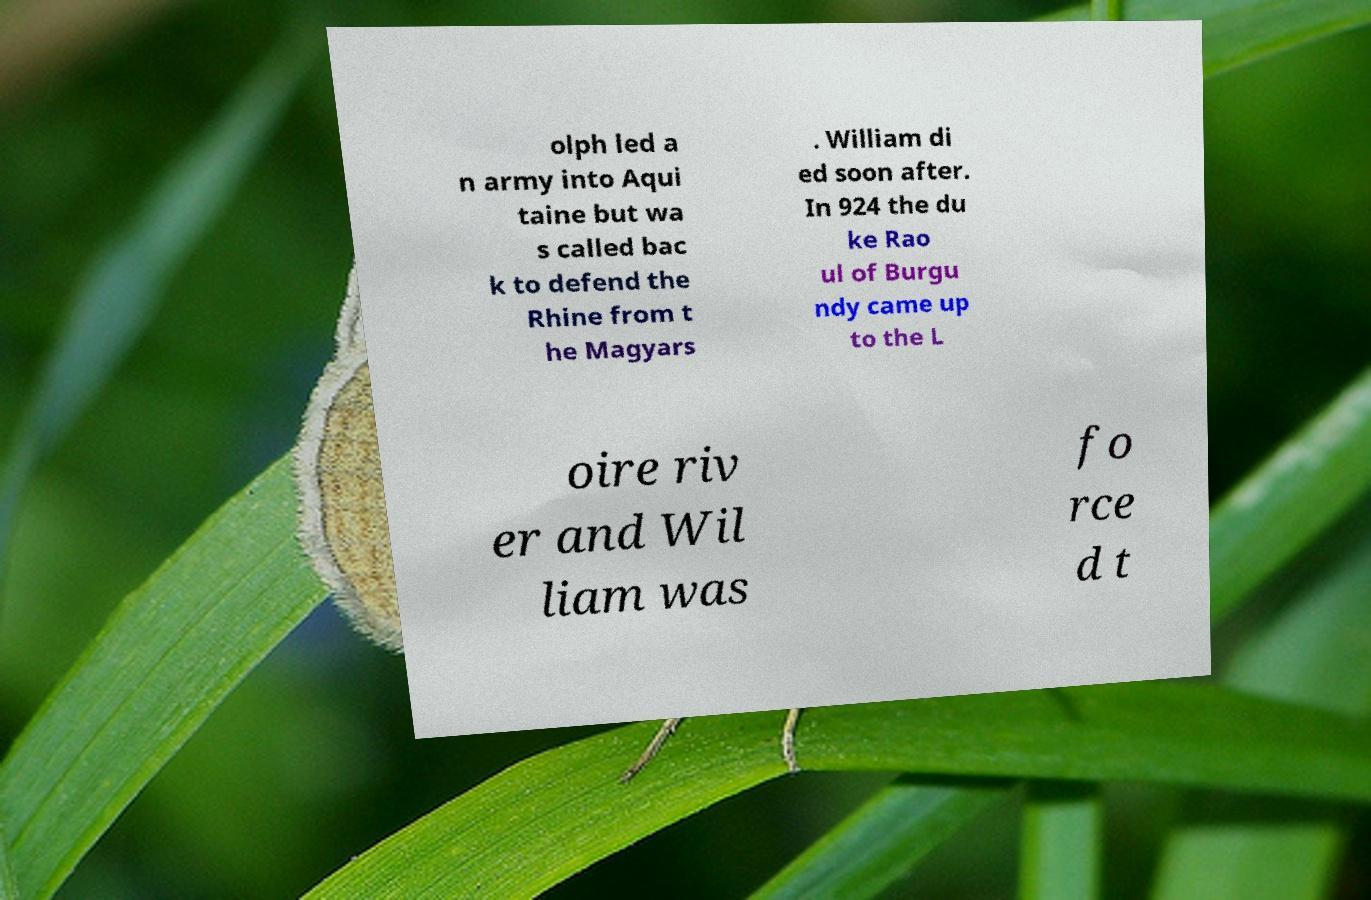Please identify and transcribe the text found in this image. olph led a n army into Aqui taine but wa s called bac k to defend the Rhine from t he Magyars . William di ed soon after. In 924 the du ke Rao ul of Burgu ndy came up to the L oire riv er and Wil liam was fo rce d t 